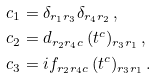<formula> <loc_0><loc_0><loc_500><loc_500>c _ { 1 } & = \delta _ { r _ { 1 } r _ { 3 } } \delta _ { r _ { 4 } r _ { 2 } } \, , \\ c _ { 2 } & = d _ { r _ { 2 } r _ { 4 } c } \, ( t ^ { c } ) _ { r _ { 3 } r _ { 1 } } \, , \\ c _ { 3 } & = i f _ { r _ { 2 } r _ { 4 } c } \, ( t ^ { c } ) _ { r _ { 3 } r _ { 1 } } \, .</formula> 